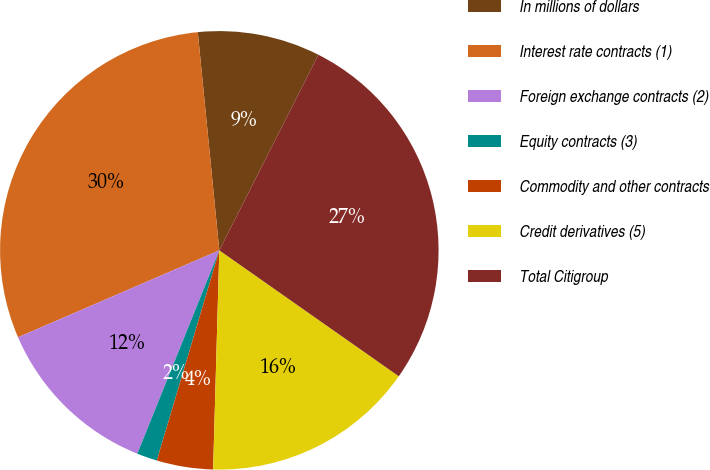Convert chart to OTSL. <chart><loc_0><loc_0><loc_500><loc_500><pie_chart><fcel>In millions of dollars<fcel>Interest rate contracts (1)<fcel>Foreign exchange contracts (2)<fcel>Equity contracts (3)<fcel>Commodity and other contracts<fcel>Credit derivatives (5)<fcel>Total Citigroup<nl><fcel>9.03%<fcel>29.92%<fcel>12.41%<fcel>1.5%<fcel>4.15%<fcel>15.71%<fcel>27.27%<nl></chart> 